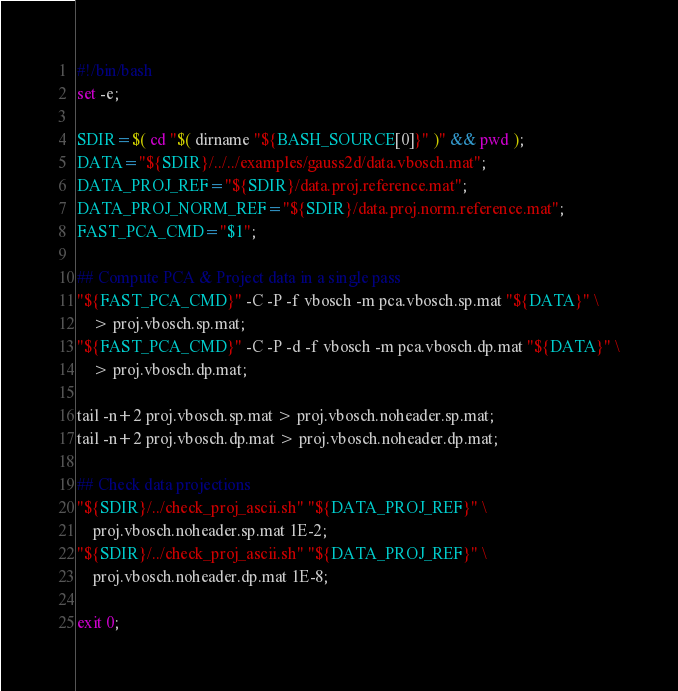<code> <loc_0><loc_0><loc_500><loc_500><_Bash_>#!/bin/bash
set -e;

SDIR=$( cd "$( dirname "${BASH_SOURCE[0]}" )" && pwd );
DATA="${SDIR}/../../examples/gauss2d/data.vbosch.mat";
DATA_PROJ_REF="${SDIR}/data.proj.reference.mat";
DATA_PROJ_NORM_REF="${SDIR}/data.proj.norm.reference.mat";
FAST_PCA_CMD="$1";

## Compute PCA & Project data in a single pass
"${FAST_PCA_CMD}" -C -P -f vbosch -m pca.vbosch.sp.mat "${DATA}" \
    > proj.vbosch.sp.mat;
"${FAST_PCA_CMD}" -C -P -d -f vbosch -m pca.vbosch.dp.mat "${DATA}" \
    > proj.vbosch.dp.mat;

tail -n+2 proj.vbosch.sp.mat > proj.vbosch.noheader.sp.mat;
tail -n+2 proj.vbosch.dp.mat > proj.vbosch.noheader.dp.mat;

## Check data projections
"${SDIR}/../check_proj_ascii.sh" "${DATA_PROJ_REF}" \
    proj.vbosch.noheader.sp.mat 1E-2;
"${SDIR}/../check_proj_ascii.sh" "${DATA_PROJ_REF}" \
    proj.vbosch.noheader.dp.mat 1E-8;

exit 0;
</code> 